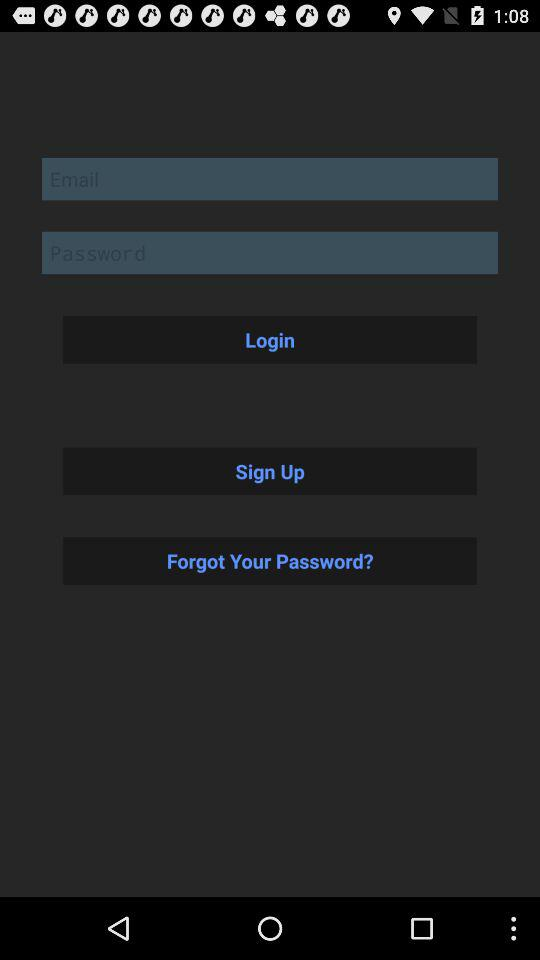How many text inputs are on the screen?
Answer the question using a single word or phrase. 2 